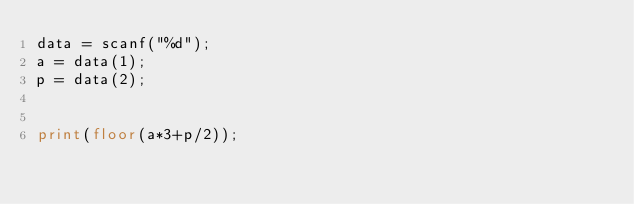<code> <loc_0><loc_0><loc_500><loc_500><_Octave_>data = scanf("%d");
a = data(1);
p = data(2);


print(floor(a*3+p/2));</code> 